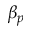Convert formula to latex. <formula><loc_0><loc_0><loc_500><loc_500>\beta _ { p }</formula> 